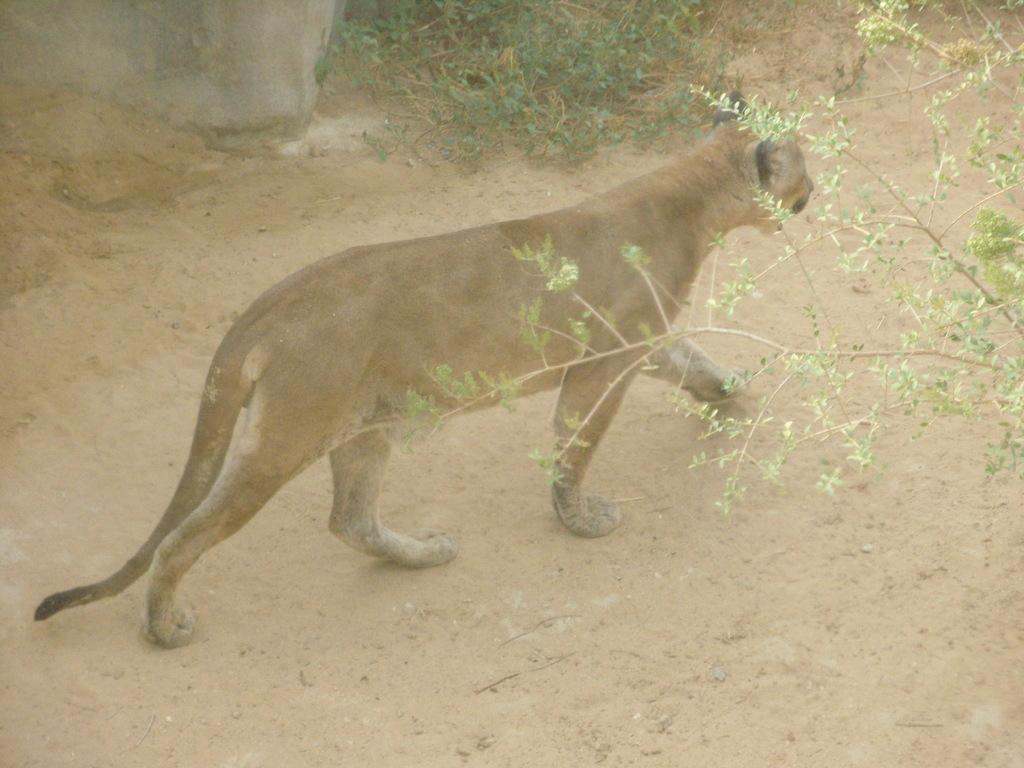What type of animal can be seen in the image? There is an animal in the image, and it is brown and white in color. What is the animal doing in the image? The animal is walking on the road in the image. What can be seen in the background of the image? There are trees visible in the image. What is the condition of the road in the image? The road appears to have mud visible in the image. What type of punishment is the animal receiving for participating in the competition in the image? There is no mention of a competition or punishment in the image; it simply shows an animal walking on the road. 